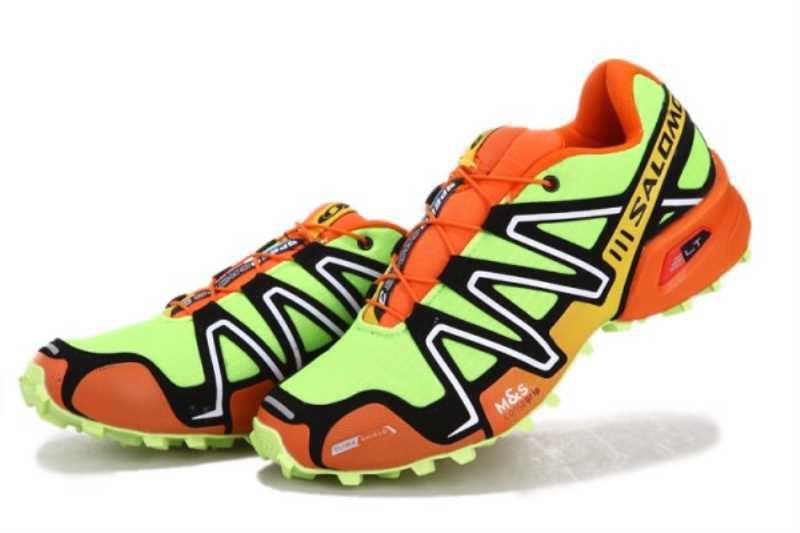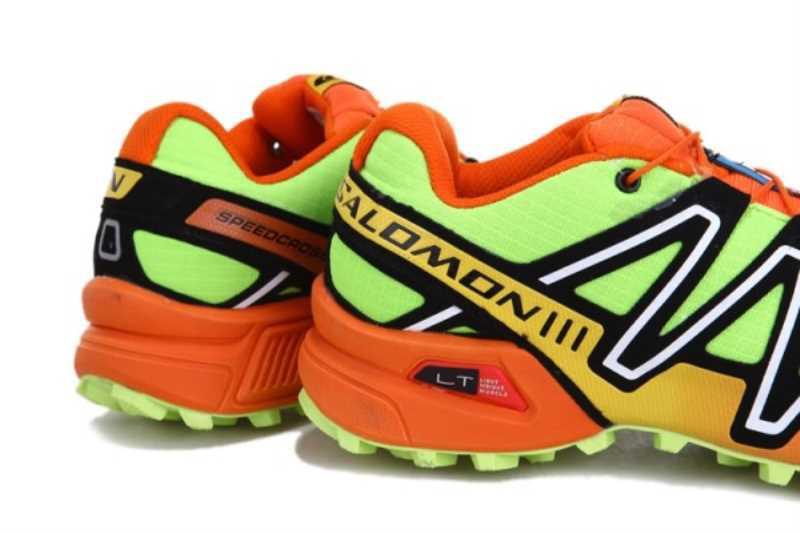The first image is the image on the left, the second image is the image on the right. Analyze the images presented: Is the assertion "Each image includes exactly one pair of sneakers." valid? Answer yes or no. Yes. The first image is the image on the left, the second image is the image on the right. Analyze the images presented: Is the assertion "One image contains at least 6 pairs of shoes." valid? Answer yes or no. No. 